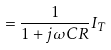Convert formula to latex. <formula><loc_0><loc_0><loc_500><loc_500>= \frac { 1 } { 1 + j \omega C R } I _ { T }</formula> 